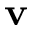Convert formula to latex. <formula><loc_0><loc_0><loc_500><loc_500>v</formula> 